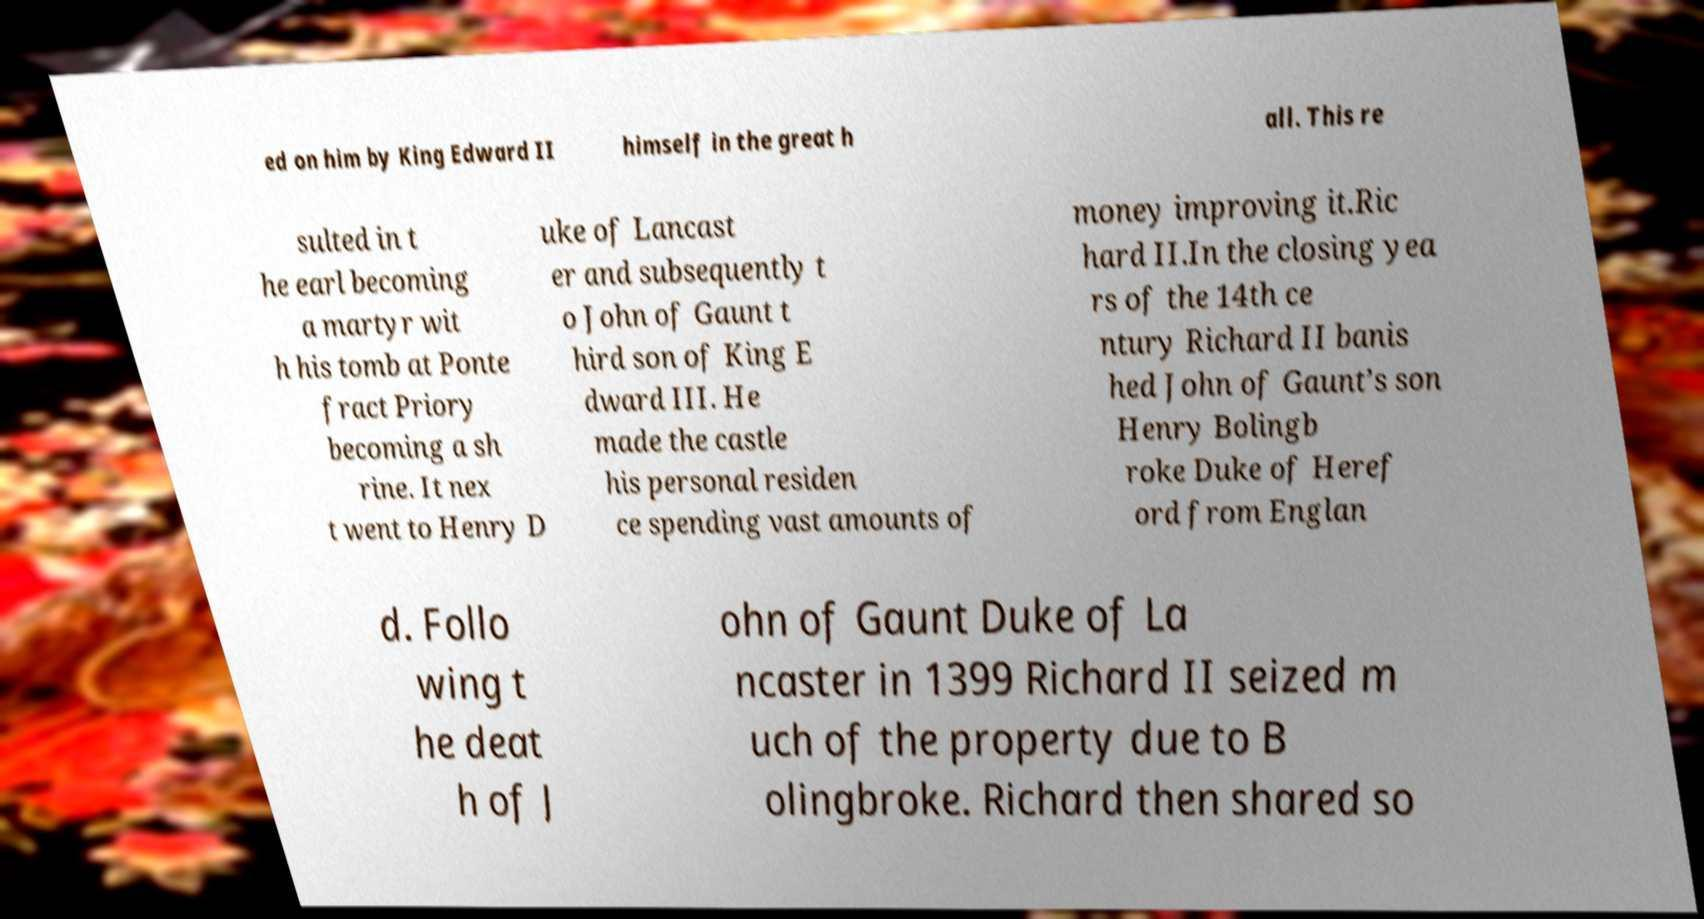Please read and relay the text visible in this image. What does it say? ed on him by King Edward II himself in the great h all. This re sulted in t he earl becoming a martyr wit h his tomb at Ponte fract Priory becoming a sh rine. It nex t went to Henry D uke of Lancast er and subsequently t o John of Gaunt t hird son of King E dward III. He made the castle his personal residen ce spending vast amounts of money improving it.Ric hard II.In the closing yea rs of the 14th ce ntury Richard II banis hed John of Gaunt’s son Henry Bolingb roke Duke of Heref ord from Englan d. Follo wing t he deat h of J ohn of Gaunt Duke of La ncaster in 1399 Richard II seized m uch of the property due to B olingbroke. Richard then shared so 